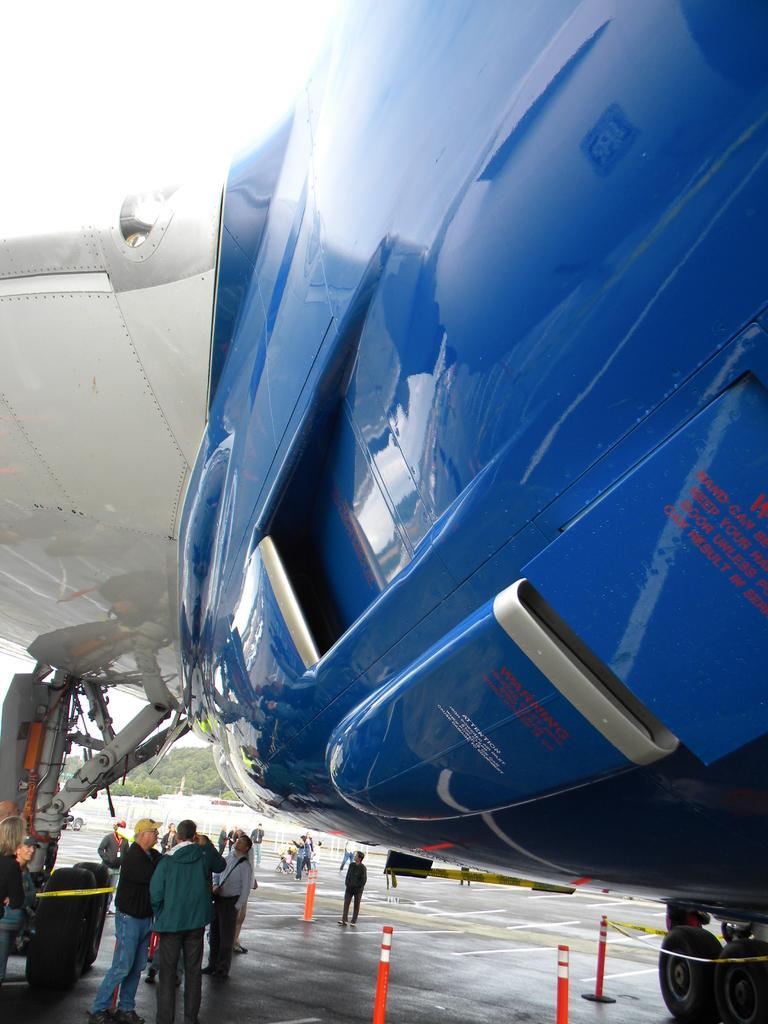Can you describe this image briefly? In the image in the center we can see one airplane,which is in blue and white color. And we can see traffic police,caution tapes,few people were standing and few other objects. 